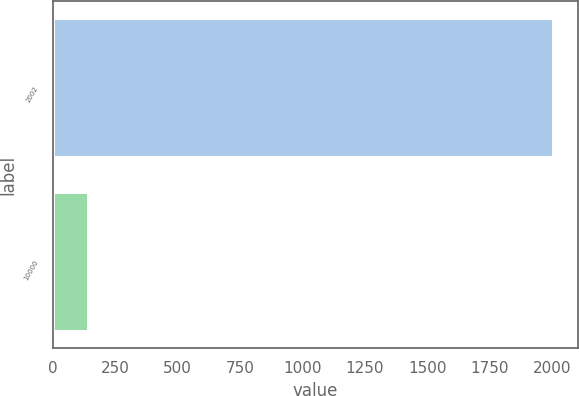Convert chart to OTSL. <chart><loc_0><loc_0><loc_500><loc_500><bar_chart><fcel>2002<fcel>10000<nl><fcel>2004<fcel>142.69<nl></chart> 